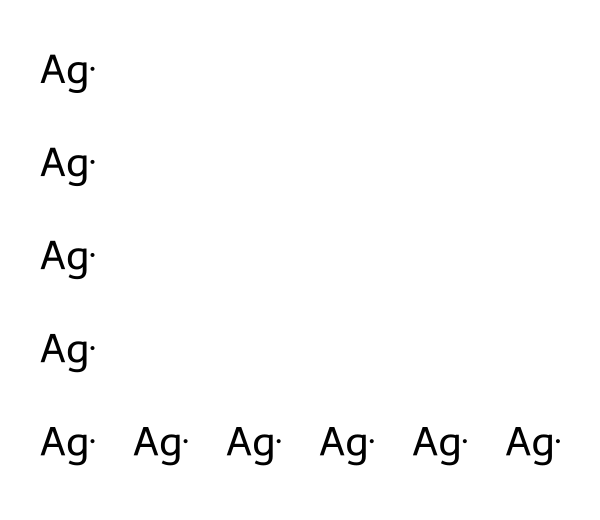What elements are present in this chemical structure? The chemical structure only contains silver atoms, indicated by the repeated "Ag" in the SMILES representation.
Answer: silver How many silver atoms are there? The SMILES representation shows ten instances of the silver atom "Ag," indicating there are ten atoms total.
Answer: ten What type of coating is represented by these silver nanoparticles? Silver nanoparticles are commonly used for antimicrobial coatings due to their ability to inhibit microbial growth.
Answer: antimicrobial Why are silver nanoparticles effective in preventing infections? Silver nanoparticles have unique properties, such as high surface area and ability to release silver ions effectively, that disrupt bacterial functions.
Answer: disrupt bacteria What is the significance of the arrangement of silver nanoparticles in coatings? The arrangement affects the distribution, interaction with microbes, and overall effectiveness of the antimicrobial activity of the coating.
Answer: affects effectiveness 